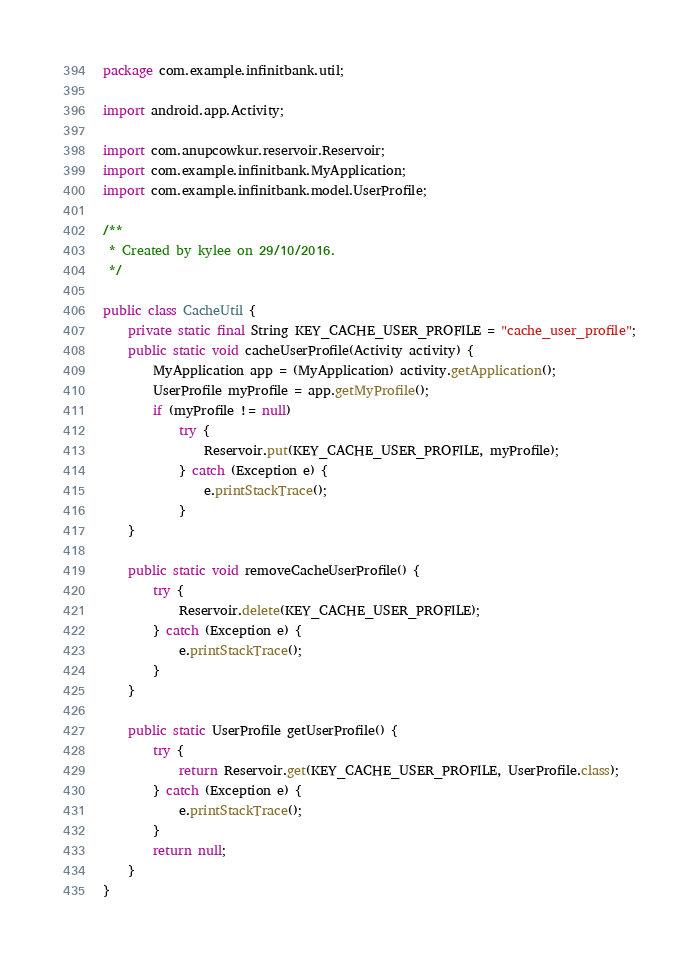Convert code to text. <code><loc_0><loc_0><loc_500><loc_500><_Java_>package com.example.infinitbank.util;

import android.app.Activity;

import com.anupcowkur.reservoir.Reservoir;
import com.example.infinitbank.MyApplication;
import com.example.infinitbank.model.UserProfile;

/**
 * Created by kylee on 29/10/2016.
 */

public class CacheUtil {
    private static final String KEY_CACHE_USER_PROFILE = "cache_user_profile";
    public static void cacheUserProfile(Activity activity) {
        MyApplication app = (MyApplication) activity.getApplication();
        UserProfile myProfile = app.getMyProfile();
        if (myProfile != null)
            try {
                Reservoir.put(KEY_CACHE_USER_PROFILE, myProfile);
            } catch (Exception e) {
                e.printStackTrace();
            }
    }

    public static void removeCacheUserProfile() {
        try {
            Reservoir.delete(KEY_CACHE_USER_PROFILE);
        } catch (Exception e) {
            e.printStackTrace();
        }
    }

    public static UserProfile getUserProfile() {
        try {
            return Reservoir.get(KEY_CACHE_USER_PROFILE, UserProfile.class);
        } catch (Exception e) {
            e.printStackTrace();
        }
        return null;
    }
}
</code> 